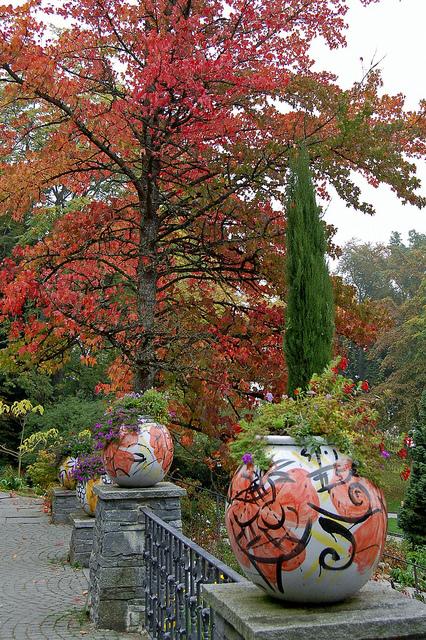How many planter pots are visible?
Short answer required. 2. What color are the leaves in the forest?
Short answer required. Red. How many different trees are in the picture?
Keep it brief. 5. 